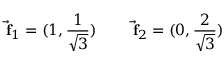<formula> <loc_0><loc_0><loc_500><loc_500>\vec { f } _ { 1 } = ( 1 , { \frac { 1 } { \sqrt { 3 } } } ) \quad \vec { f } _ { 2 } = ( 0 , { \frac { 2 } { \sqrt { 3 } } } )</formula> 